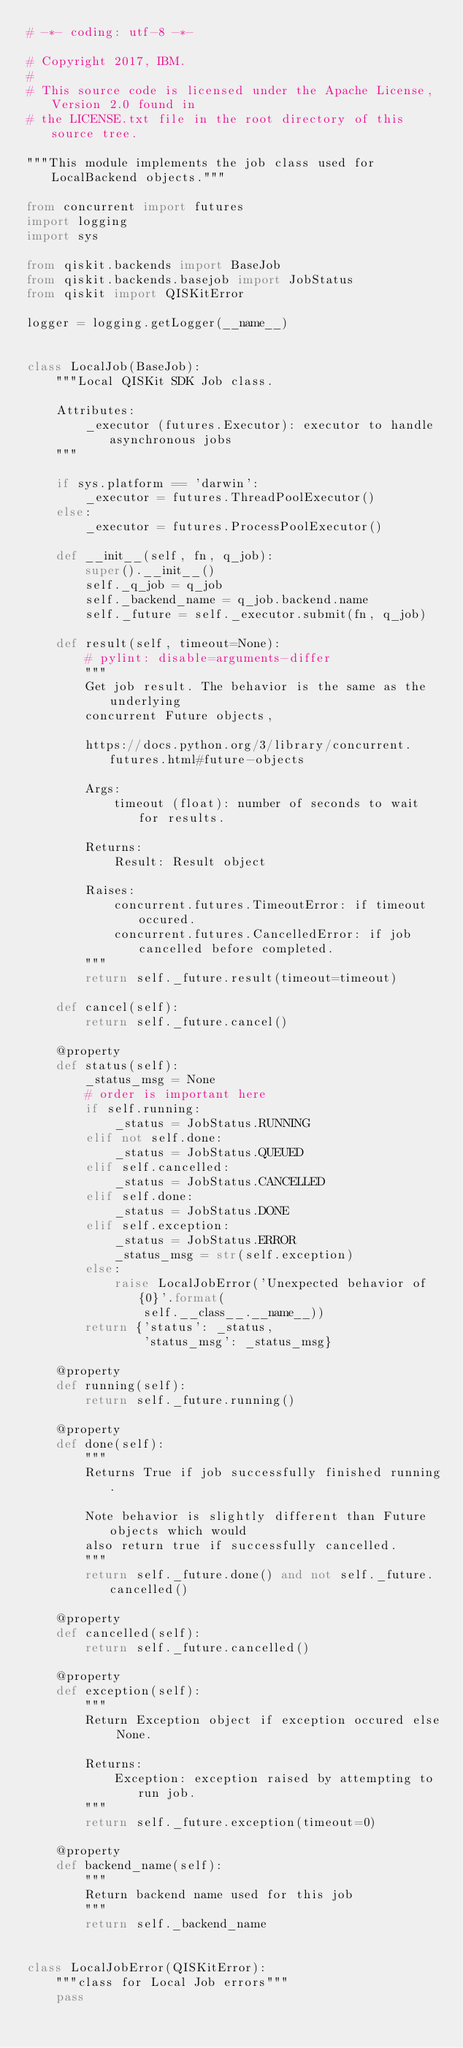Convert code to text. <code><loc_0><loc_0><loc_500><loc_500><_Python_># -*- coding: utf-8 -*-

# Copyright 2017, IBM.
#
# This source code is licensed under the Apache License, Version 2.0 found in
# the LICENSE.txt file in the root directory of this source tree.

"""This module implements the job class used for LocalBackend objects."""

from concurrent import futures
import logging
import sys

from qiskit.backends import BaseJob
from qiskit.backends.basejob import JobStatus
from qiskit import QISKitError

logger = logging.getLogger(__name__)


class LocalJob(BaseJob):
    """Local QISKit SDK Job class.

    Attributes:
        _executor (futures.Executor): executor to handle asynchronous jobs
    """

    if sys.platform == 'darwin':
        _executor = futures.ThreadPoolExecutor()
    else:
        _executor = futures.ProcessPoolExecutor()

    def __init__(self, fn, q_job):
        super().__init__()
        self._q_job = q_job
        self._backend_name = q_job.backend.name
        self._future = self._executor.submit(fn, q_job)

    def result(self, timeout=None):
        # pylint: disable=arguments-differ
        """
        Get job result. The behavior is the same as the underlying
        concurrent Future objects,

        https://docs.python.org/3/library/concurrent.futures.html#future-objects

        Args:
            timeout (float): number of seconds to wait for results.

        Returns:
            Result: Result object

        Raises:
            concurrent.futures.TimeoutError: if timeout occured.
            concurrent.futures.CancelledError: if job cancelled before completed.
        """
        return self._future.result(timeout=timeout)

    def cancel(self):
        return self._future.cancel()

    @property
    def status(self):
        _status_msg = None
        # order is important here
        if self.running:
            _status = JobStatus.RUNNING
        elif not self.done:
            _status = JobStatus.QUEUED
        elif self.cancelled:
            _status = JobStatus.CANCELLED
        elif self.done:
            _status = JobStatus.DONE
        elif self.exception:
            _status = JobStatus.ERROR
            _status_msg = str(self.exception)
        else:
            raise LocalJobError('Unexpected behavior of {0}'.format(
                self.__class__.__name__))
        return {'status': _status,
                'status_msg': _status_msg}

    @property
    def running(self):
        return self._future.running()

    @property
    def done(self):
        """
        Returns True if job successfully finished running.

        Note behavior is slightly different than Future objects which would
        also return true if successfully cancelled.
        """
        return self._future.done() and not self._future.cancelled()

    @property
    def cancelled(self):
        return self._future.cancelled()

    @property
    def exception(self):
        """
        Return Exception object if exception occured else None.

        Returns:
            Exception: exception raised by attempting to run job.
        """
        return self._future.exception(timeout=0)

    @property
    def backend_name(self):
        """
        Return backend name used for this job
        """
        return self._backend_name


class LocalJobError(QISKitError):
    """class for Local Job errors"""
    pass
</code> 